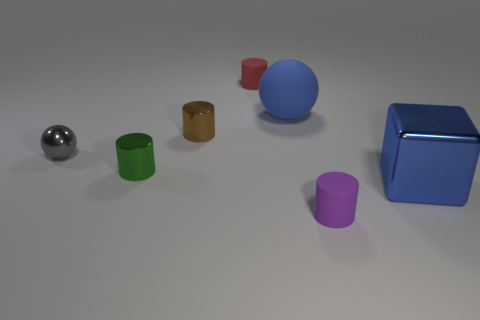What kind of setting or application could these objects be a part of? These objects could be part of an educational set designed to teach about geometry, spatial reasoning, or color differentiation. Alternatively, they might represent components in a minimalist artistic installation or a 3D modeling software showcase. 